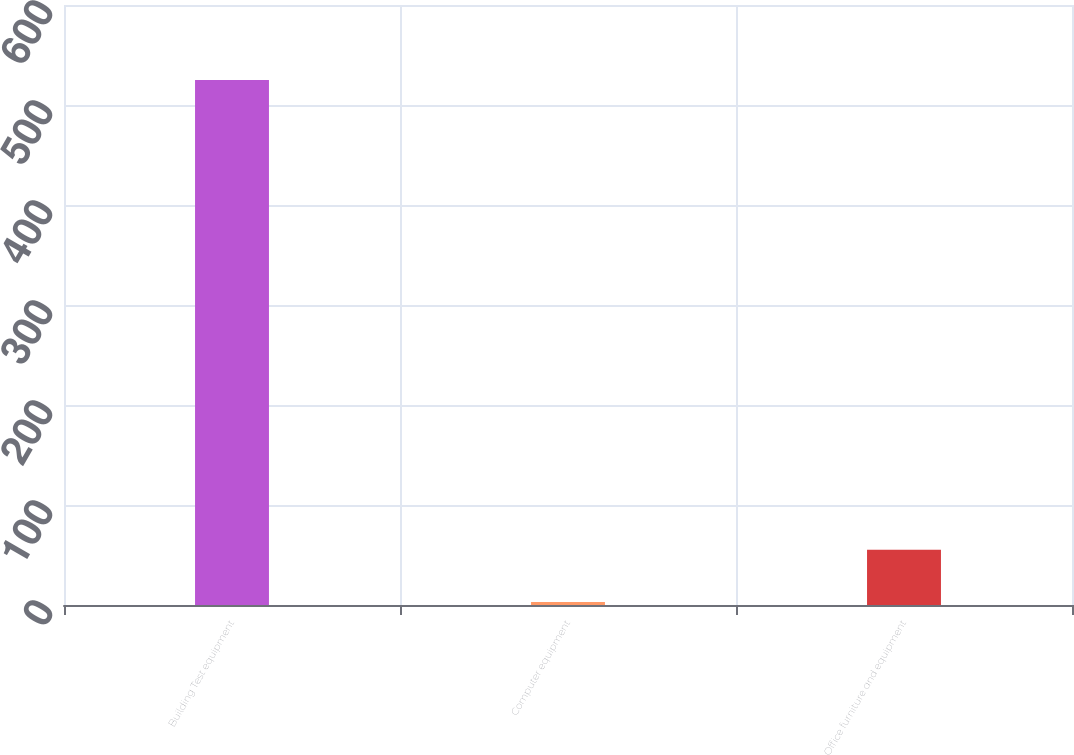Convert chart. <chart><loc_0><loc_0><loc_500><loc_500><bar_chart><fcel>Building Test equipment<fcel>Computer equipment<fcel>Office furniture and equipment<nl><fcel>525<fcel>3<fcel>55.2<nl></chart> 